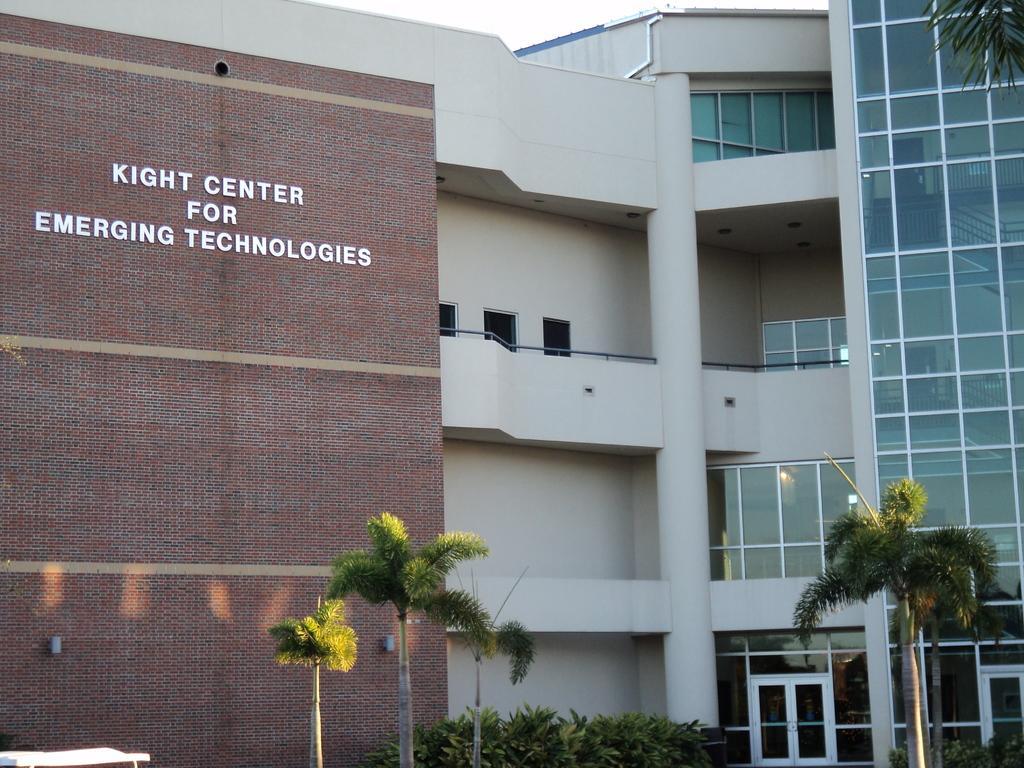In one or two sentences, can you explain what this image depicts? In this image, we can see a building with some text. There are a few trees, plants. We can see an object on the bottom left. We can also see the sky and some glass. 